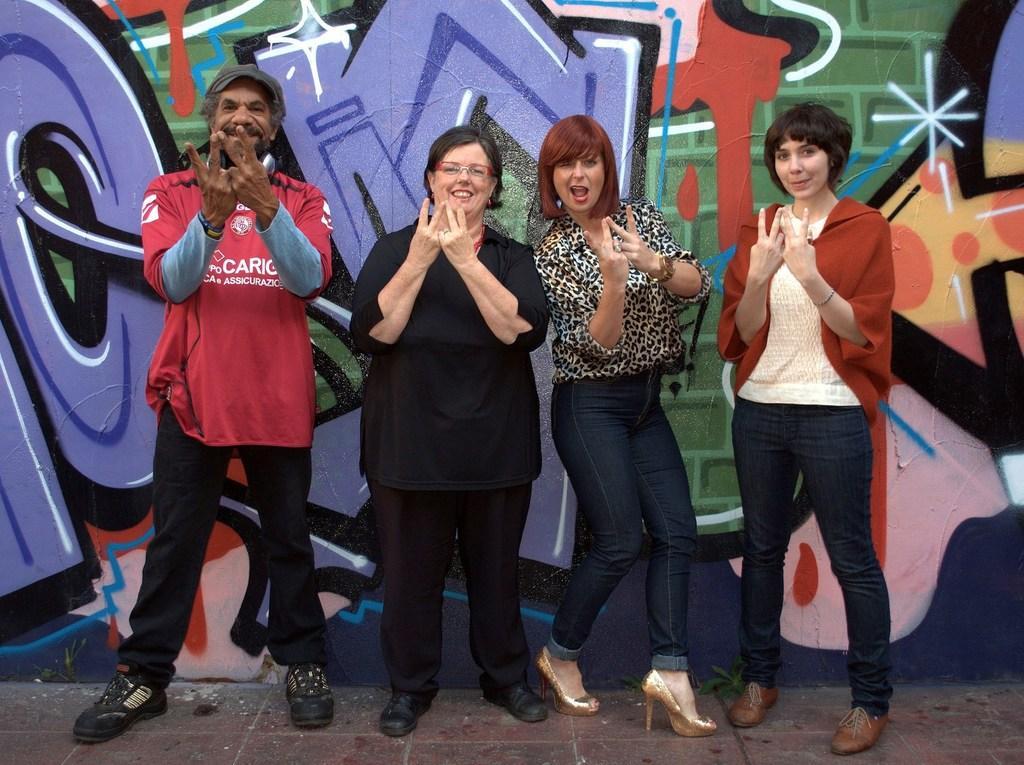Describe this image in one or two sentences. In this image, there are four persons standing on the floor and smiling. In the background, I can see the graffiti painting on the wall. 